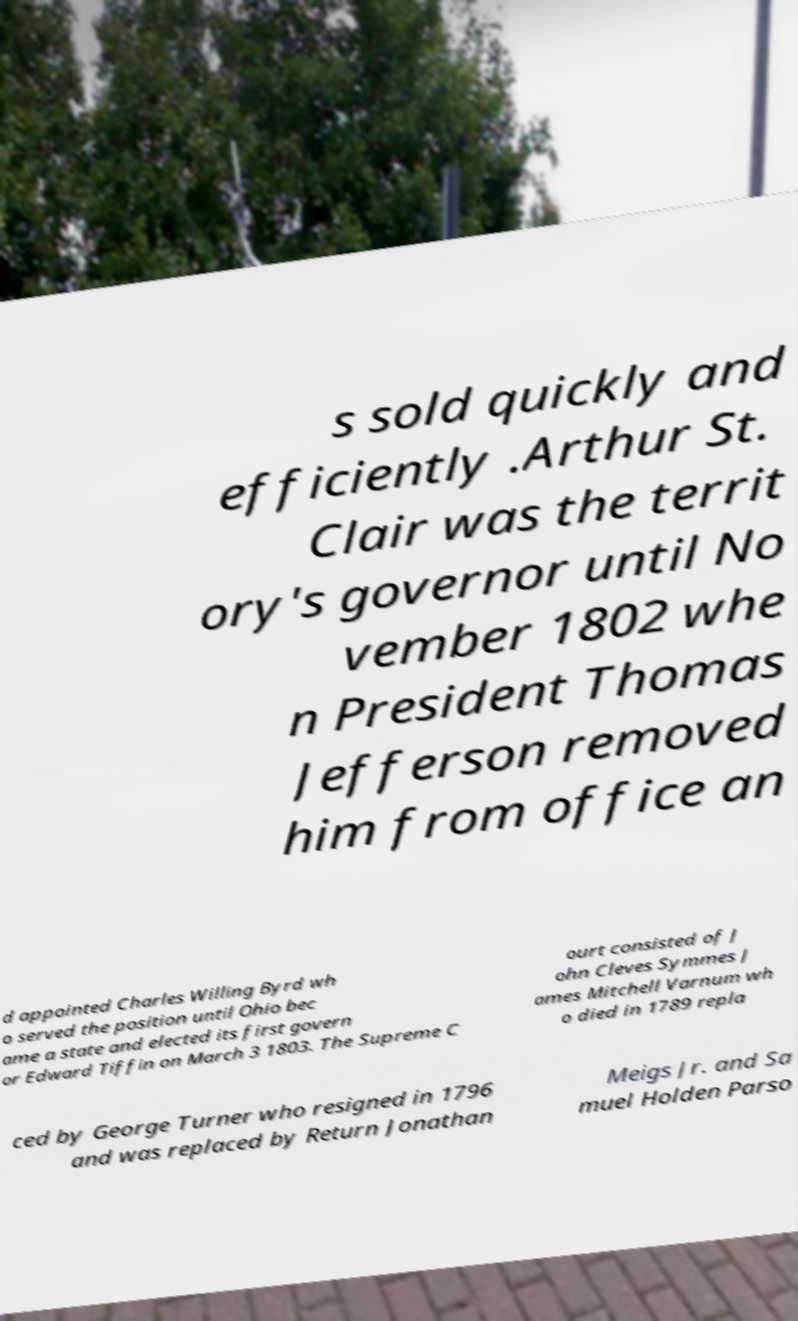There's text embedded in this image that I need extracted. Can you transcribe it verbatim? s sold quickly and efficiently .Arthur St. Clair was the territ ory's governor until No vember 1802 whe n President Thomas Jefferson removed him from office an d appointed Charles Willing Byrd wh o served the position until Ohio bec ame a state and elected its first govern or Edward Tiffin on March 3 1803. The Supreme C ourt consisted of J ohn Cleves Symmes J ames Mitchell Varnum wh o died in 1789 repla ced by George Turner who resigned in 1796 and was replaced by Return Jonathan Meigs Jr. and Sa muel Holden Parso 